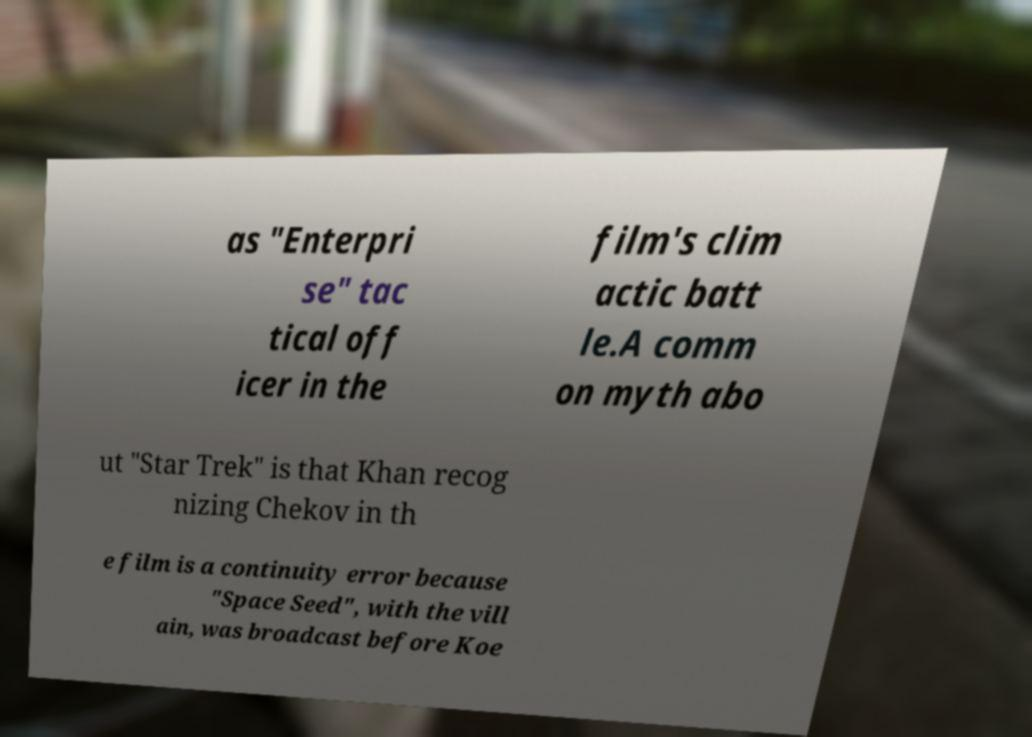I need the written content from this picture converted into text. Can you do that? as "Enterpri se" tac tical off icer in the film's clim actic batt le.A comm on myth abo ut "Star Trek" is that Khan recog nizing Chekov in th e film is a continuity error because "Space Seed", with the vill ain, was broadcast before Koe 